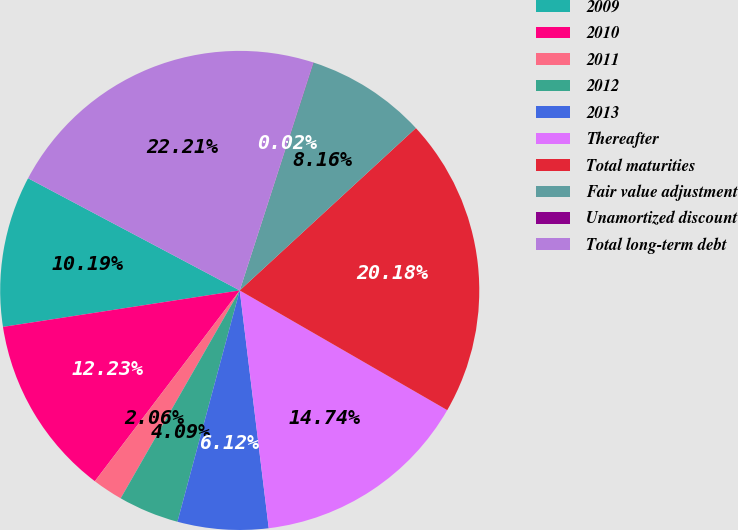Convert chart. <chart><loc_0><loc_0><loc_500><loc_500><pie_chart><fcel>2009<fcel>2010<fcel>2011<fcel>2012<fcel>2013<fcel>Thereafter<fcel>Total maturities<fcel>Fair value adjustment<fcel>Unamortized discount<fcel>Total long-term debt<nl><fcel>10.19%<fcel>12.23%<fcel>2.06%<fcel>4.09%<fcel>6.12%<fcel>14.74%<fcel>20.18%<fcel>8.16%<fcel>0.02%<fcel>22.21%<nl></chart> 